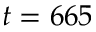<formula> <loc_0><loc_0><loc_500><loc_500>t = 6 6 5</formula> 